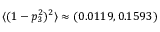Convert formula to latex. <formula><loc_0><loc_0><loc_500><loc_500>\langle ( 1 - p _ { 3 } ^ { 2 } ) ^ { 2 } \rangle \approx ( 0 . 0 1 1 9 , 0 . 1 5 9 3 )</formula> 